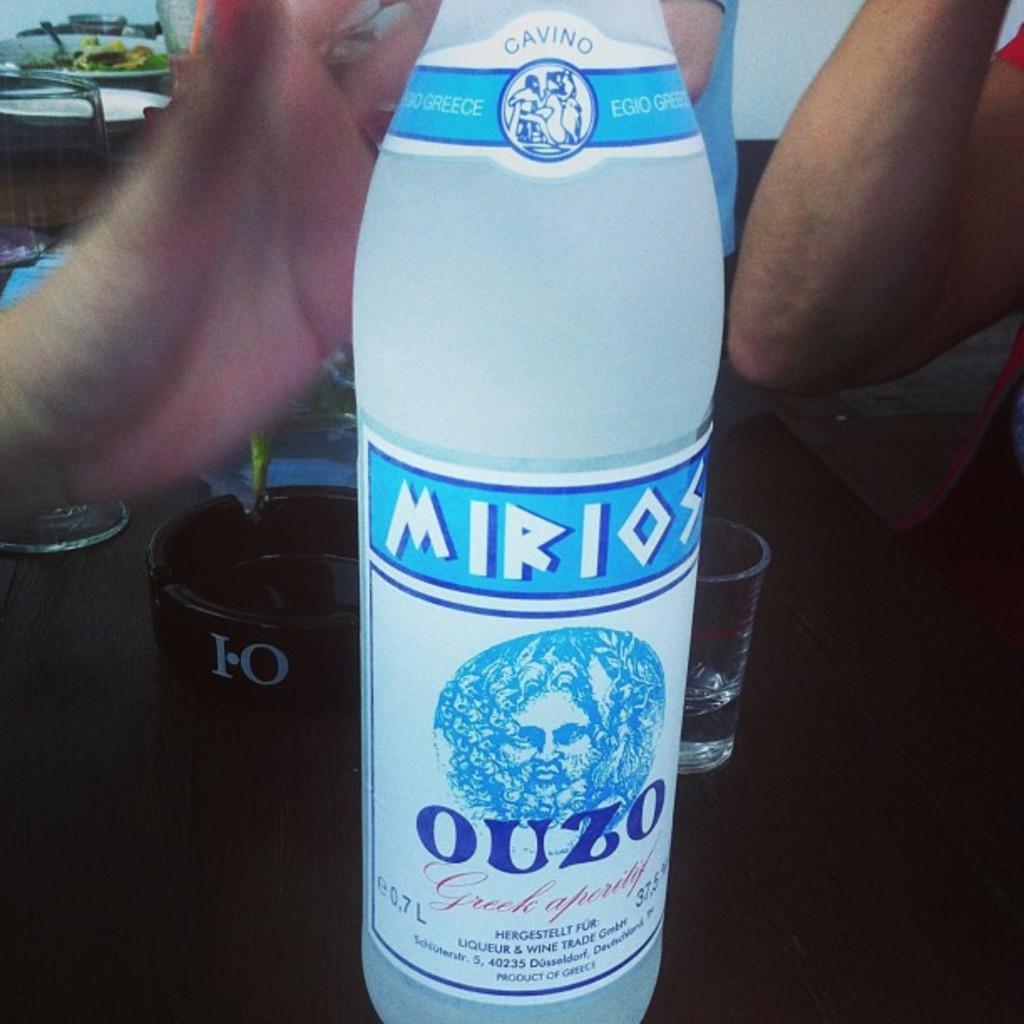In one or two sentences, can you explain what this image depicts? In this picture one bottle is present on the table and behind it one glass and ash tray is present and at the right corner one person is sitting. 